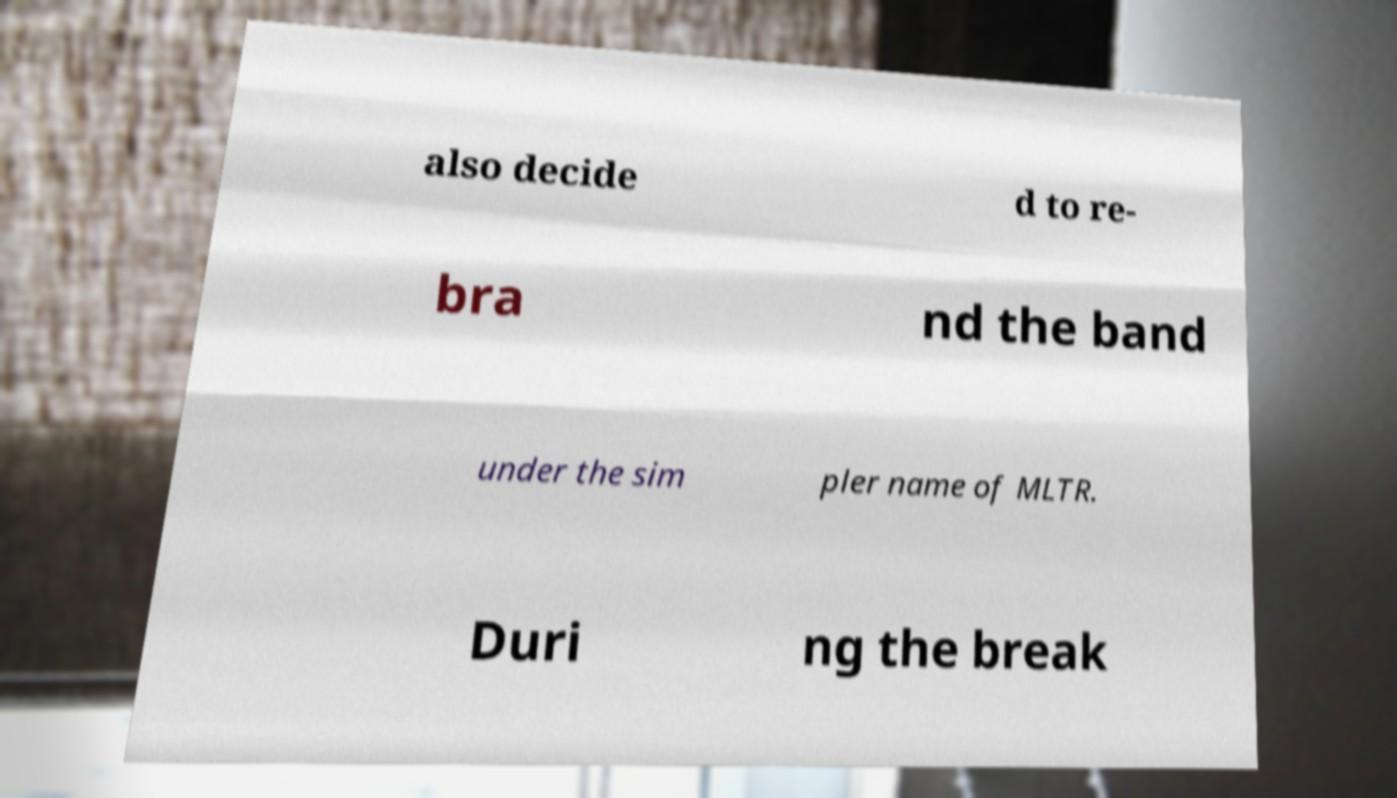For documentation purposes, I need the text within this image transcribed. Could you provide that? also decide d to re- bra nd the band under the sim pler name of MLTR. Duri ng the break 